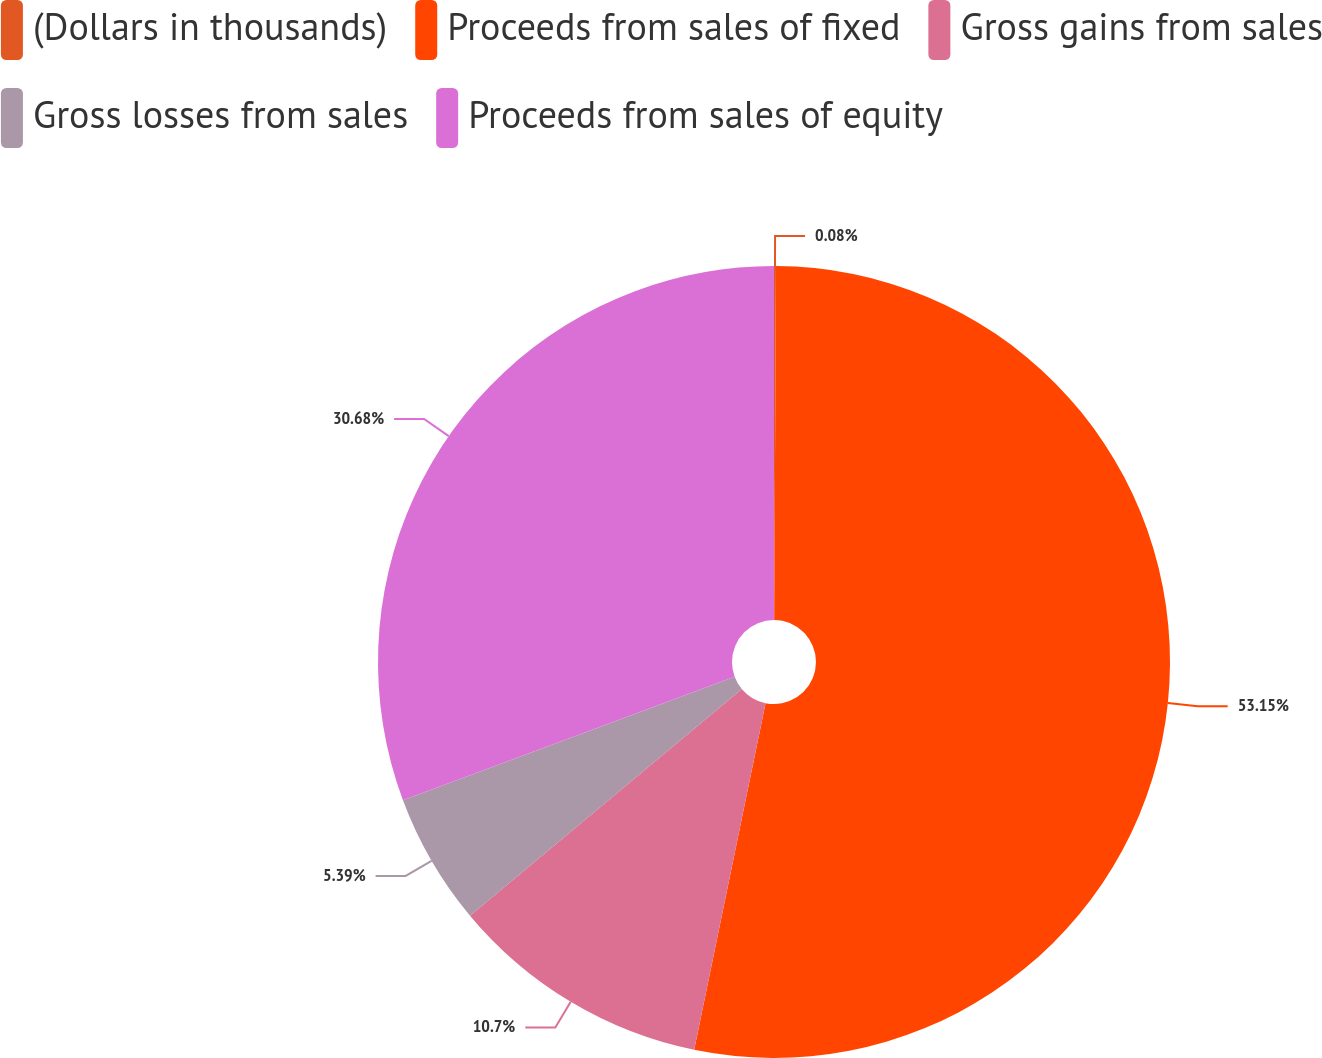Convert chart to OTSL. <chart><loc_0><loc_0><loc_500><loc_500><pie_chart><fcel>(Dollars in thousands)<fcel>Proceeds from sales of fixed<fcel>Gross gains from sales<fcel>Gross losses from sales<fcel>Proceeds from sales of equity<nl><fcel>0.08%<fcel>53.15%<fcel>10.7%<fcel>5.39%<fcel>30.68%<nl></chart> 